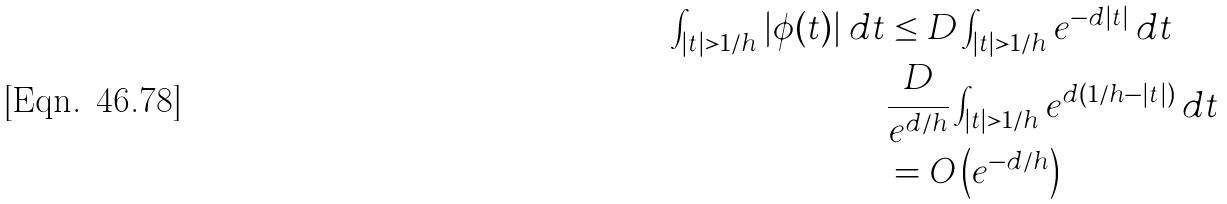Convert formula to latex. <formula><loc_0><loc_0><loc_500><loc_500>\int _ { | t | > 1 / h } | \phi ( t ) | \, d t & \leq D \int _ { | t | > 1 / h } e ^ { - d | t | } \, d t \\ & \frac { D } { e ^ { d / h } } \int _ { | t | > 1 / h } e ^ { d ( 1 / h - | t | ) } \, d t \\ & = O \left ( e ^ { - d / h } \right )</formula> 